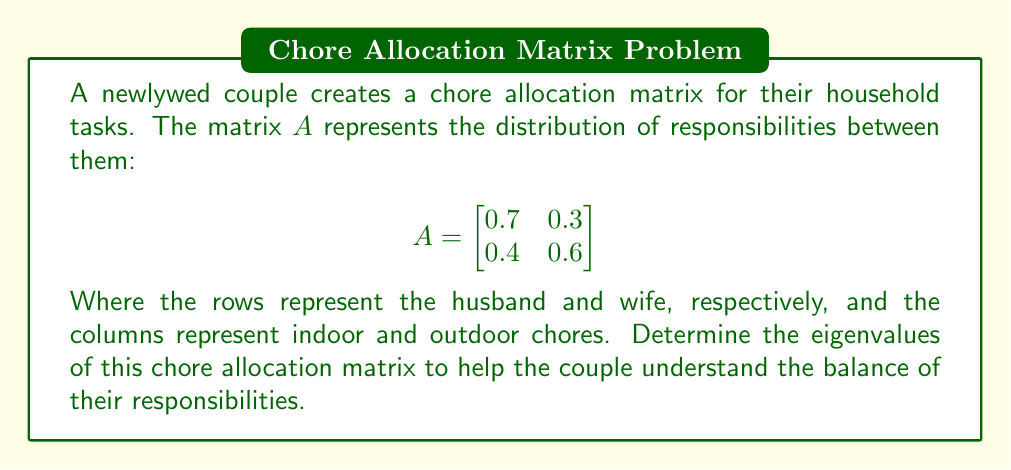Could you help me with this problem? To find the eigenvalues of matrix $A$, we need to solve the characteristic equation:

1) First, we set up the equation $det(A - \lambda I) = 0$, where $\lambda$ represents the eigenvalues and $I$ is the 2x2 identity matrix:

   $$det\begin{pmatrix}
   0.7 - \lambda & 0.3 \\
   0.4 & 0.6 - \lambda
   \end{pmatrix} = 0$$

2) Expand the determinant:
   $$(0.7 - \lambda)(0.6 - \lambda) - (0.3)(0.4) = 0$$

3) Multiply the terms:
   $$0.42 - 0.7\lambda - 0.6\lambda + \lambda^2 - 0.12 = 0$$

4) Simplify:
   $$\lambda^2 - 1.3\lambda + 0.3 = 0$$

5) This is a quadratic equation. We can solve it using the quadratic formula:
   $$\lambda = \frac{-b \pm \sqrt{b^2 - 4ac}}{2a}$$
   where $a=1$, $b=-1.3$, and $c=0.3$

6) Substituting these values:
   $$\lambda = \frac{1.3 \pm \sqrt{1.69 - 1.2}}{2} = \frac{1.3 \pm \sqrt{0.49}}{2} = \frac{1.3 \pm 0.7}{2}$$

7) Therefore, the two eigenvalues are:
   $$\lambda_1 = \frac{1.3 + 0.7}{2} = 1$$
   $$\lambda_2 = \frac{1.3 - 0.7}{2} = 0.3$$
Answer: $\lambda_1 = 1$, $\lambda_2 = 0.3$ 